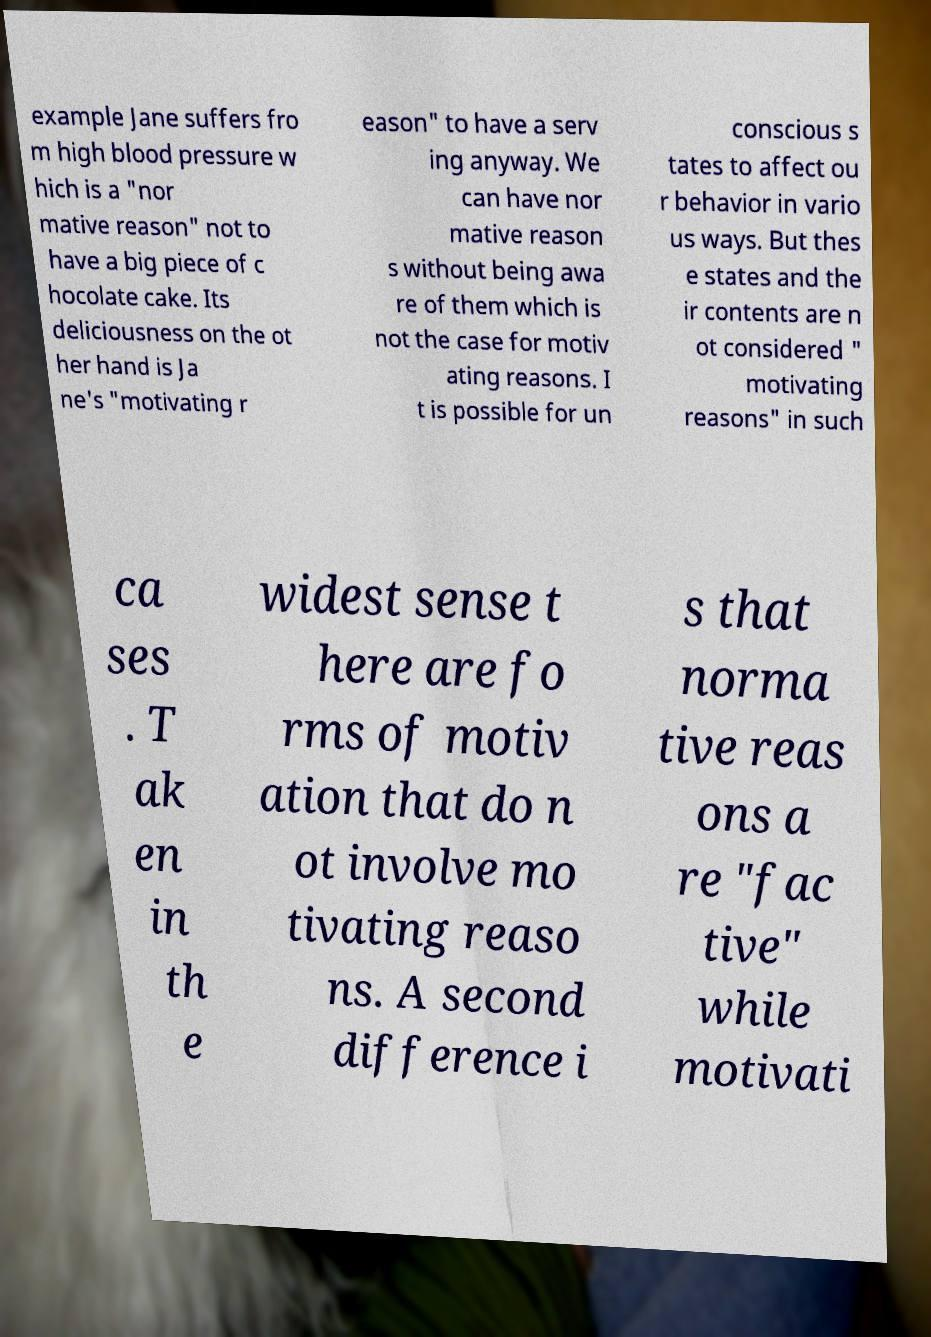There's text embedded in this image that I need extracted. Can you transcribe it verbatim? example Jane suffers fro m high blood pressure w hich is a "nor mative reason" not to have a big piece of c hocolate cake. Its deliciousness on the ot her hand is Ja ne's "motivating r eason" to have a serv ing anyway. We can have nor mative reason s without being awa re of them which is not the case for motiv ating reasons. I t is possible for un conscious s tates to affect ou r behavior in vario us ways. But thes e states and the ir contents are n ot considered " motivating reasons" in such ca ses . T ak en in th e widest sense t here are fo rms of motiv ation that do n ot involve mo tivating reaso ns. A second difference i s that norma tive reas ons a re "fac tive" while motivati 